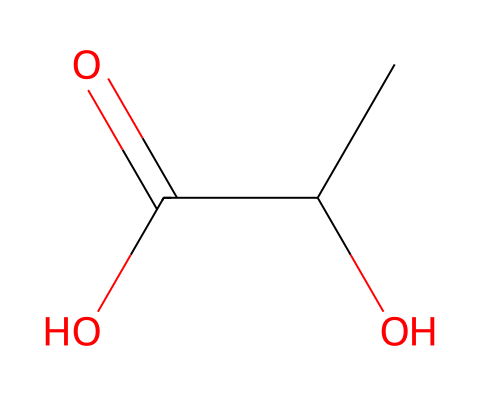What is the chemical name of this compound? The SMILES representation CC(O)C(=O)O corresponds to Lactic acid; the presence of the hydroxyl group (O) and the carboxylic acid group (C(=O)O) helps identify it as such.
Answer: Lactic acid How many carbon atoms are in this chemical? Analyzing the SMILES code, there are two carbon atoms (C) indicated in the structure.
Answer: 2 What type of acid is lactic acid? Lactic acid is classified as an organic acid due to its structure containing carbon, hydrogen, and oxygen, specifically a carboxylic acid functional group.
Answer: organic acid What is the significance of the hydroxyl group in lactic acid? The hydroxyl group (–OH) influences the solubility and reactivity of lactic acid, making it more polar and enhancing its nature as a biodegradable substance.
Answer: solubility Which functional group indicates that lactic acid is an acid? The carboxylic acid functional group (C(=O)O) denotes that lactic acid can donate protons, characteristic of acids.
Answer: carboxylic acid How does lactic acid contribute to biodegradability in plastics? Lactic acid polylactic acid (PLA) provides a renewable source as it can be synthesized from biomass, promoting sustainability compared to traditional petroleum-based plastics.
Answer: renewable source 